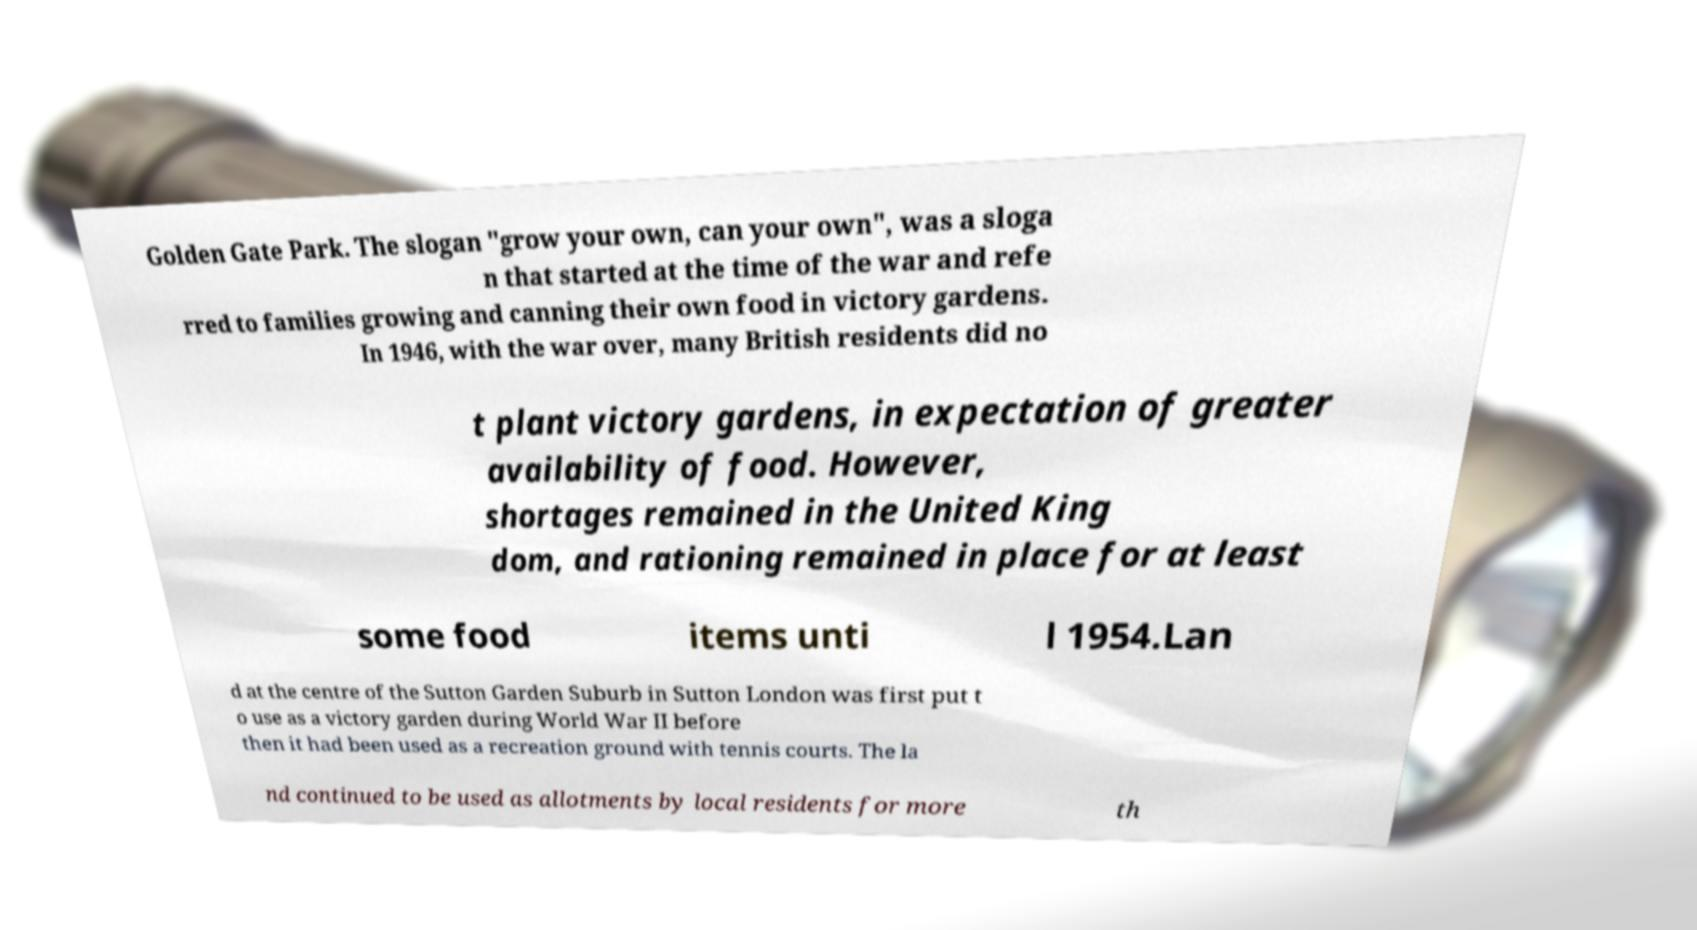Can you read and provide the text displayed in the image?This photo seems to have some interesting text. Can you extract and type it out for me? Golden Gate Park. The slogan "grow your own, can your own", was a sloga n that started at the time of the war and refe rred to families growing and canning their own food in victory gardens. In 1946, with the war over, many British residents did no t plant victory gardens, in expectation of greater availability of food. However, shortages remained in the United King dom, and rationing remained in place for at least some food items unti l 1954.Lan d at the centre of the Sutton Garden Suburb in Sutton London was first put t o use as a victory garden during World War II before then it had been used as a recreation ground with tennis courts. The la nd continued to be used as allotments by local residents for more th 